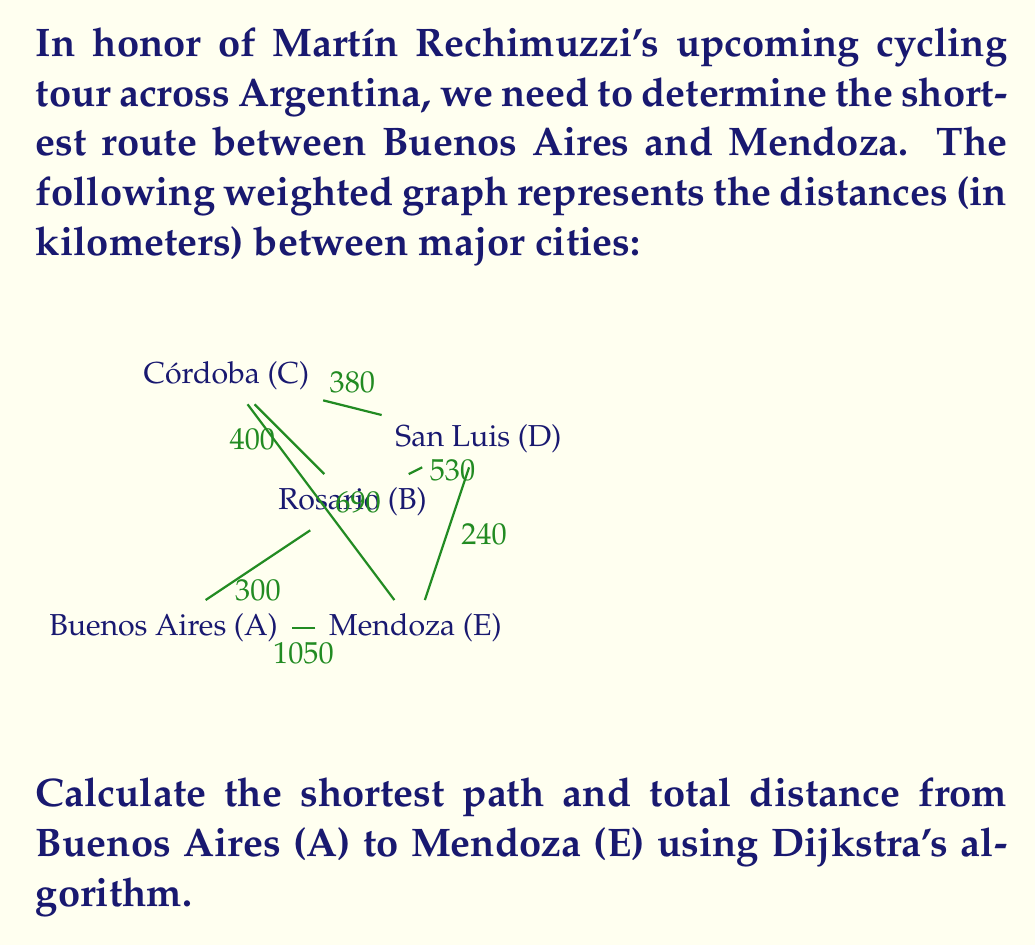What is the answer to this math problem? To solve this problem, we'll use Dijkstra's algorithm to find the shortest path from Buenos Aires (A) to Mendoza (E). Let's follow the steps:

1) Initialize:
   - Set distance to A as 0, and all other nodes as infinity.
   - Set all nodes as unvisited.
   - Set A as the current node.

2) For the current node, consider all unvisited neighbors and calculate their tentative distances.
   - From A: B = 300, E = 1050

3) Mark the current node as visited. A is now visited.

4) Select the unvisited node with the smallest tentative distance as the new current node.
   - B becomes the current node.

5) Repeat steps 2-4:
   - From B: C = 300 + 400 = 700, D = 300 + 530 = 830
   - Mark B as visited
   - C becomes the current node
   - From C: D = 700 + 380 = 1080, E = 700 + 690 = 1390
   - Mark C as visited
   - D becomes the current node
   - From D: E = 830 + 240 = 1070
   - Mark D as visited
   - E becomes the current node (all nodes visited)

6) The algorithm ends as we've reached our destination E.

The shortest path is A → B → D → E with a total distance of 1070 km.

This route takes Martín Rechimuzzi from Buenos Aires through Rosario and San Luis before reaching Mendoza, optimizing his cycling journey.
Answer: The shortest path from Buenos Aires to Mendoza is A → B → D → E, with a total distance of 1070 km. 